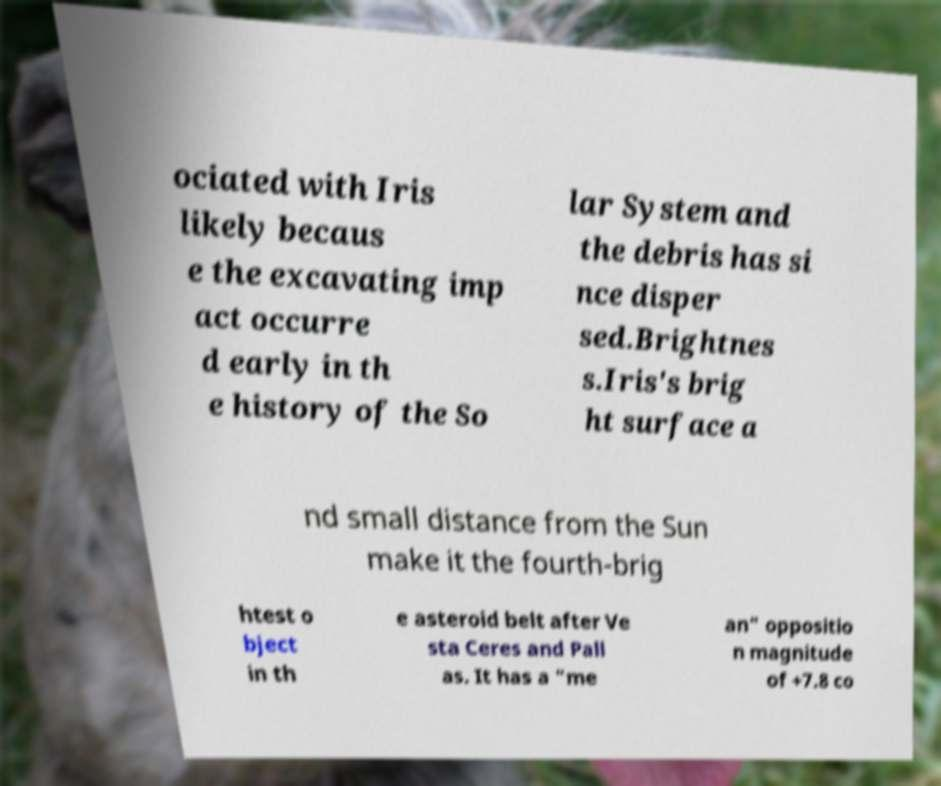What messages or text are displayed in this image? I need them in a readable, typed format. ociated with Iris likely becaus e the excavating imp act occurre d early in th e history of the So lar System and the debris has si nce disper sed.Brightnes s.Iris's brig ht surface a nd small distance from the Sun make it the fourth-brig htest o bject in th e asteroid belt after Ve sta Ceres and Pall as. It has a "me an" oppositio n magnitude of +7.8 co 